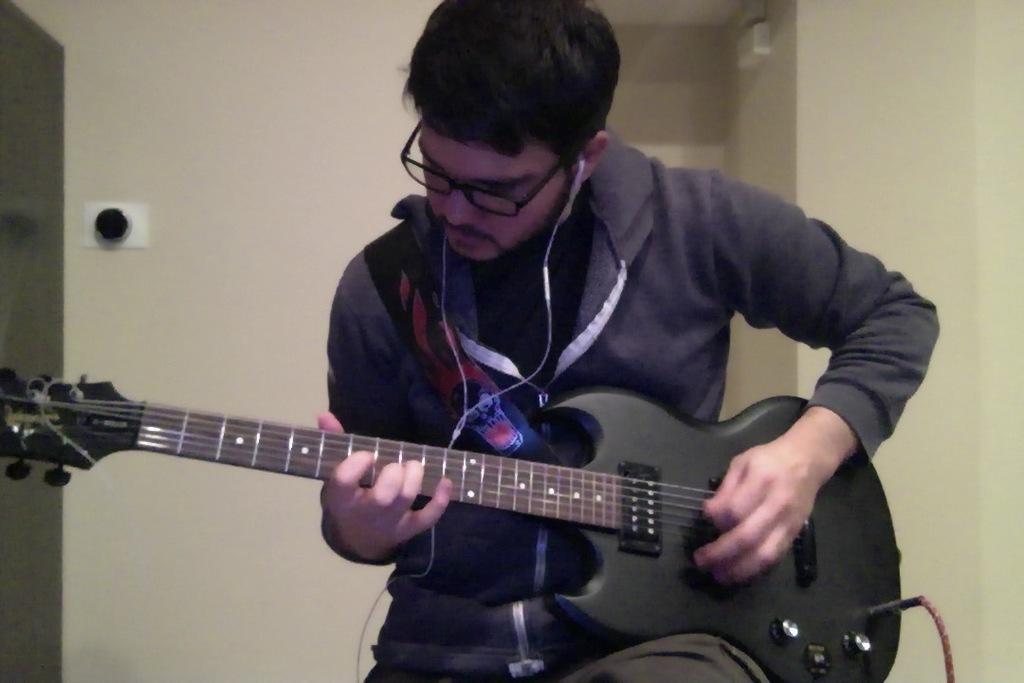In one or two sentences, can you explain what this image depicts? In this image I can see a person playing the guitar. 